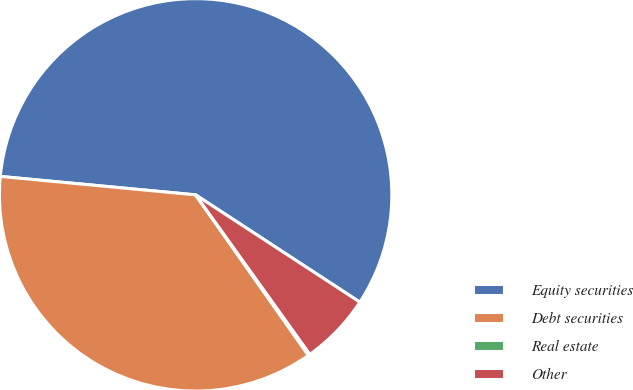<chart> <loc_0><loc_0><loc_500><loc_500><pie_chart><fcel>Equity securities<fcel>Debt securities<fcel>Real estate<fcel>Other<nl><fcel>57.71%<fcel>36.25%<fcel>0.14%<fcel>5.9%<nl></chart> 